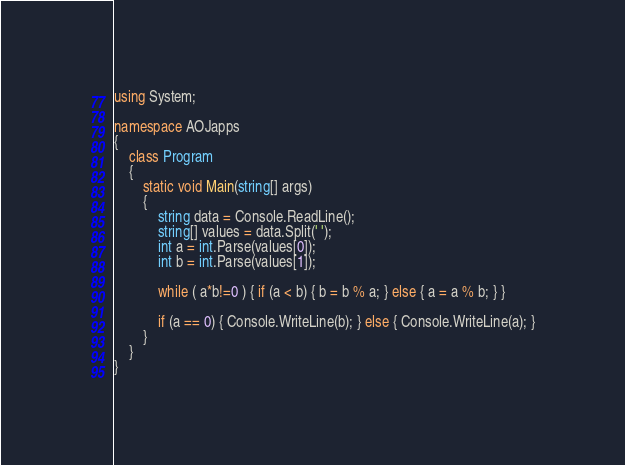<code> <loc_0><loc_0><loc_500><loc_500><_C#_>using System;

namespace AOJapps
{
    class Program
    {
        static void Main(string[] args)
        {
            string data = Console.ReadLine();
            string[] values = data.Split(' ');
            int a = int.Parse(values[0]);
            int b = int.Parse(values[1]);

            while ( a*b!=0 ) { if (a < b) { b = b % a; } else { a = a % b; } }
            
            if (a == 0) { Console.WriteLine(b); } else { Console.WriteLine(a); }
        }
    }
}</code> 